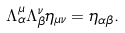<formula> <loc_0><loc_0><loc_500><loc_500>\Lambda ^ { \mu } _ { \alpha } \Lambda ^ { \nu } _ { \beta } \eta _ { \mu \nu } = \eta _ { \alpha \beta } .</formula> 